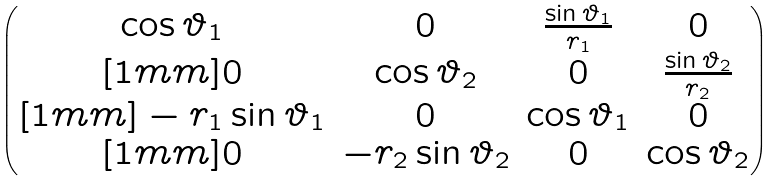<formula> <loc_0><loc_0><loc_500><loc_500>\begin{pmatrix} \cos \vartheta _ { 1 } & 0 & \frac { \sin \vartheta _ { 1 } } { r _ { 1 } } & 0 \\ [ 1 m m ] 0 & \cos \vartheta _ { 2 } & 0 & \frac { \sin \vartheta _ { 2 } } { r _ { 2 } } \\ [ 1 m m ] - r _ { 1 } \sin \vartheta _ { 1 } & 0 & \cos \vartheta _ { 1 } & 0 \\ [ 1 m m ] 0 & - r _ { 2 } \sin \vartheta _ { 2 } & 0 & \cos \vartheta _ { 2 } \end{pmatrix}</formula> 